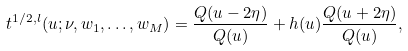Convert formula to latex. <formula><loc_0><loc_0><loc_500><loc_500>t ^ { 1 / 2 , l } ( u ; \nu , w _ { 1 } , \dots , w _ { M } ) = \frac { Q ( u - 2 \eta ) } { Q ( u ) } + h ( u ) \frac { Q ( u + 2 \eta ) } { Q ( u ) } ,</formula> 